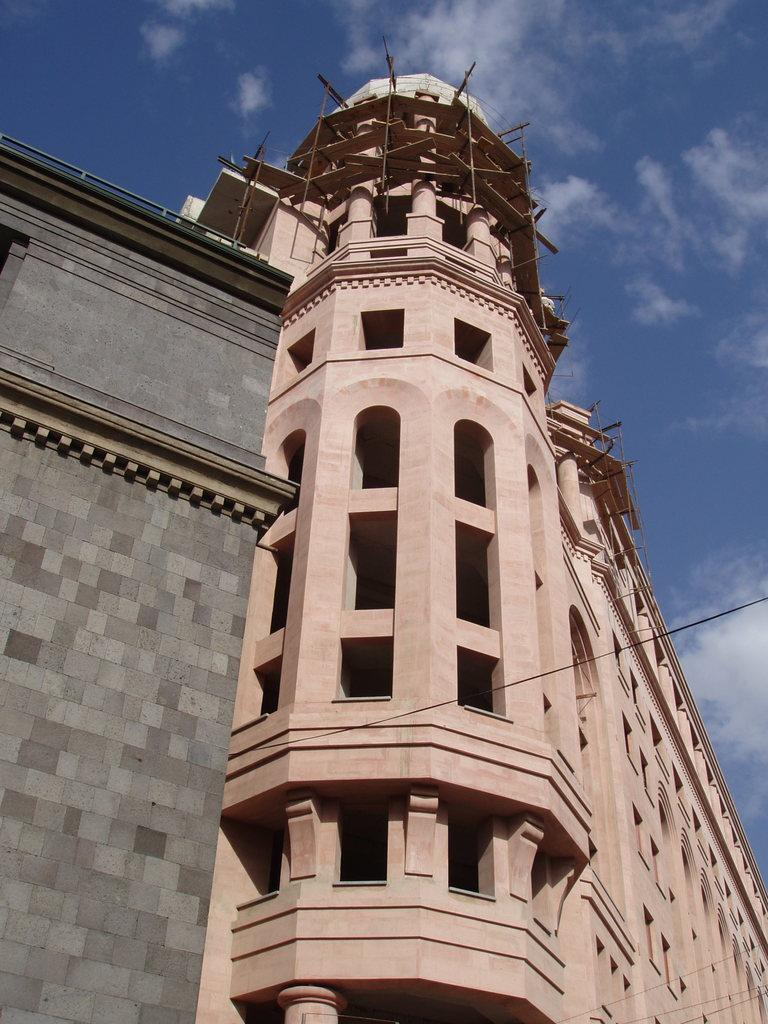What type of structures can be seen in the image? There are buildings with windows in the image. What else is visible in the image besides the buildings? Wires are visible in the image. What part of the natural environment is visible in the image? The sky is visible in the image. How would you describe the sky in the image? The sky appears to be cloudy. How many lizards are crawling on the buildings in the image? There are no lizards present in the image; it only features buildings, wires, and a cloudy sky. 